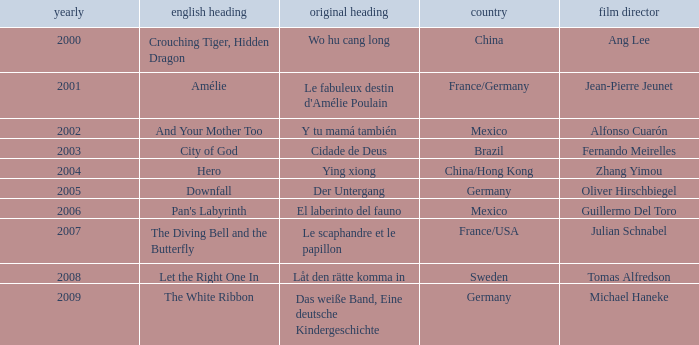Name the title of jean-pierre jeunet Amélie. 